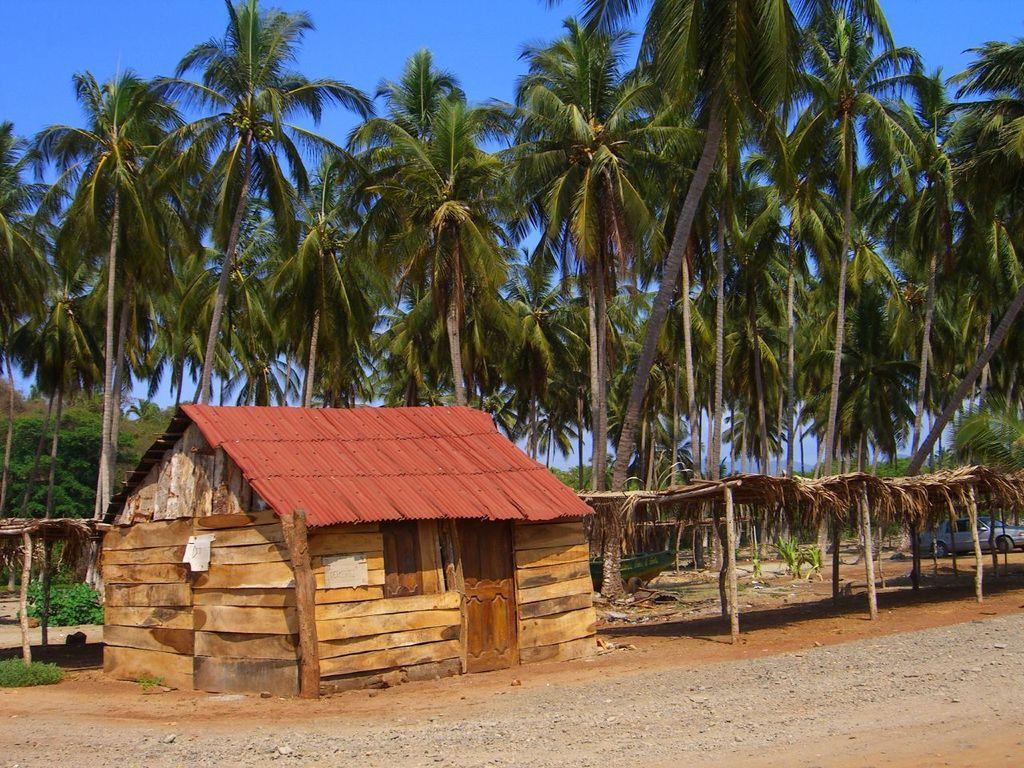What type of vegetation can be seen in the image? There are trees and plants in the image. What type of structure is present in the image? There is a shed and huts in the image. Is there any transportation visible in the image? Yes, there is a vehicle on the road in the image. What type of stone is being used to build the huts in the image? There is no mention of stone being used to build the huts in the image; the huts are not described in detail. 